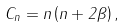<formula> <loc_0><loc_0><loc_500><loc_500>C _ { n } = n \left ( n + 2 \beta \right ) ,</formula> 